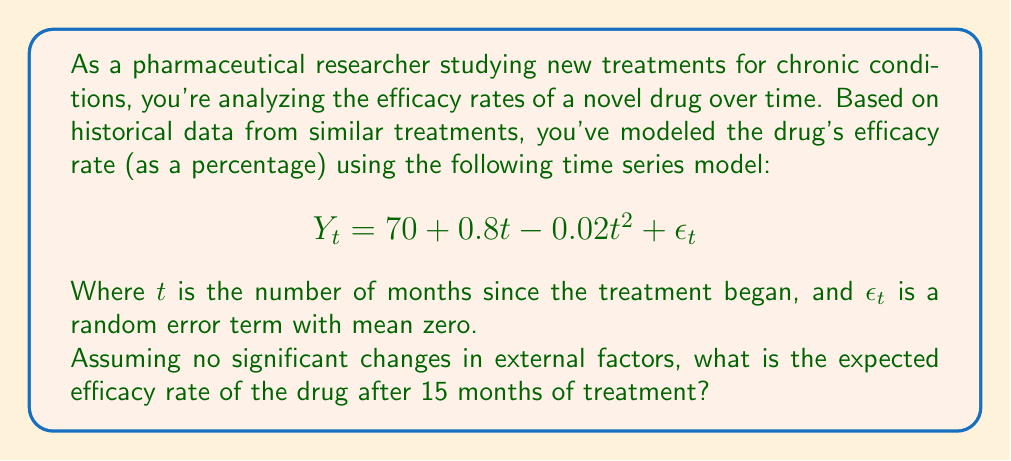Provide a solution to this math problem. To solve this problem, we need to use the given time series model and substitute the value of $t$ with 15 (for 15 months). Here's a step-by-step explanation:

1. The time series model is given as:
   $$Y_t = 70 + 0.8t - 0.02t^2 + \epsilon_t$$

2. We need to find the expected value of $Y_t$ when $t = 15$. The expected value of the error term $\epsilon_t$ is zero, so we can ignore it for this calculation.

3. Let's substitute $t = 15$ into the equation:
   $$E[Y_{15}] = 70 + 0.8(15) - 0.02(15)^2$$

4. Now, let's calculate each term:
   - $70$ remains as is
   - $0.8(15) = 12$
   - $0.02(15)^2 = 0.02(225) = 4.5$

5. Putting it all together:
   $$E[Y_{15}] = 70 + 12 - 4.5 = 77.5$$

Therefore, the expected efficacy rate after 15 months is 77.5%.
Answer: 77.5% 